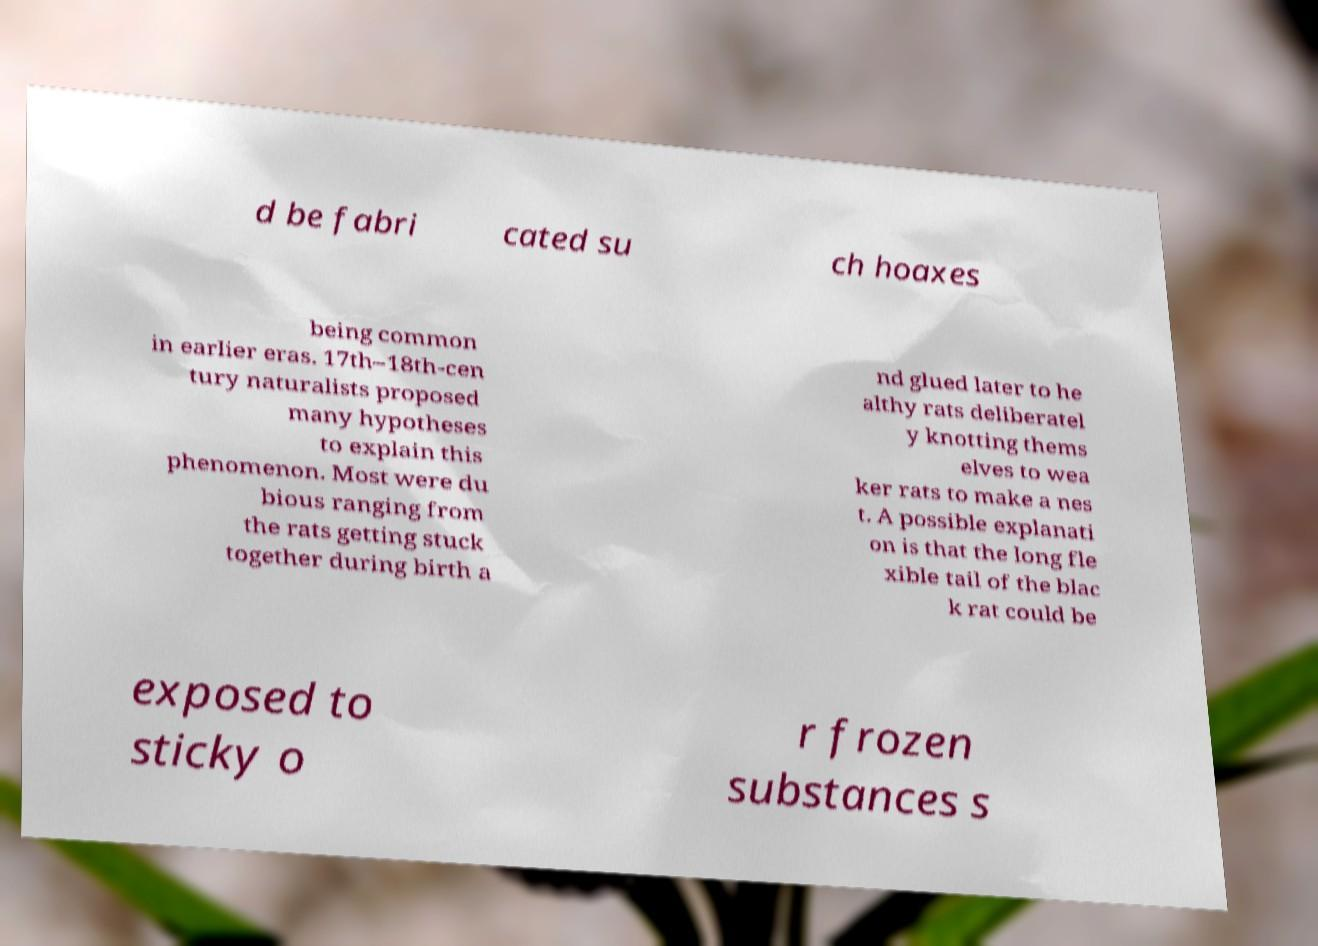I need the written content from this picture converted into text. Can you do that? d be fabri cated su ch hoaxes being common in earlier eras. 17th–18th-cen tury naturalists proposed many hypotheses to explain this phenomenon. Most were du bious ranging from the rats getting stuck together during birth a nd glued later to he althy rats deliberatel y knotting thems elves to wea ker rats to make a nes t. A possible explanati on is that the long fle xible tail of the blac k rat could be exposed to sticky o r frozen substances s 